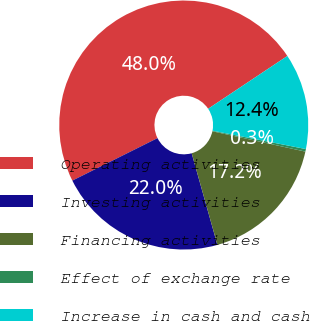Convert chart. <chart><loc_0><loc_0><loc_500><loc_500><pie_chart><fcel>Operating activities<fcel>Investing activities<fcel>Financing activities<fcel>Effect of exchange rate<fcel>Increase in cash and cash<nl><fcel>48.01%<fcel>21.99%<fcel>17.22%<fcel>0.33%<fcel>12.45%<nl></chart> 